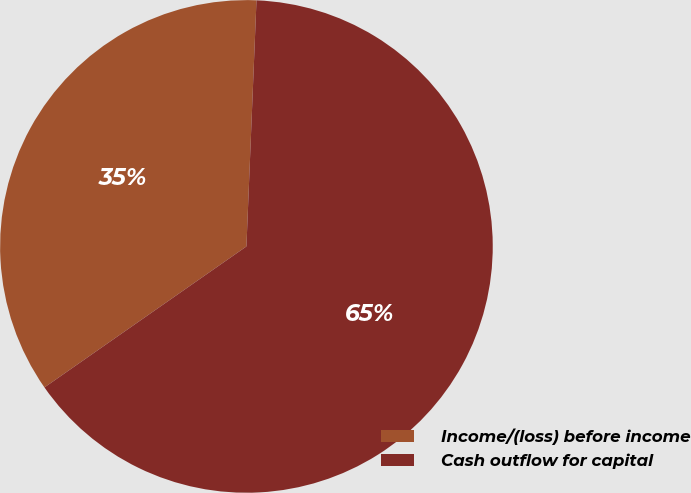<chart> <loc_0><loc_0><loc_500><loc_500><pie_chart><fcel>Income/(loss) before income<fcel>Cash outflow for capital<nl><fcel>35.35%<fcel>64.65%<nl></chart> 